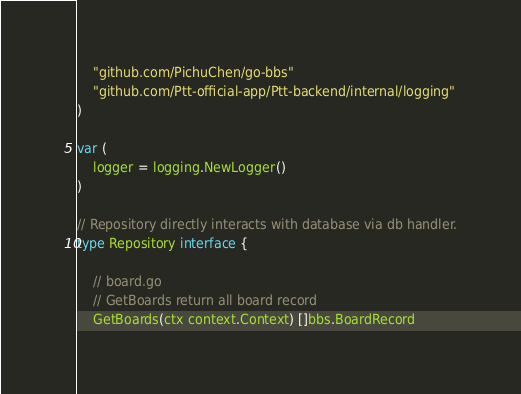Convert code to text. <code><loc_0><loc_0><loc_500><loc_500><_Go_>
	"github.com/PichuChen/go-bbs"
	"github.com/Ptt-official-app/Ptt-backend/internal/logging"
)

var (
	logger = logging.NewLogger()
)

// Repository directly interacts with database via db handler.
type Repository interface {

	// board.go
	// GetBoards return all board record
	GetBoards(ctx context.Context) []bbs.BoardRecord</code> 